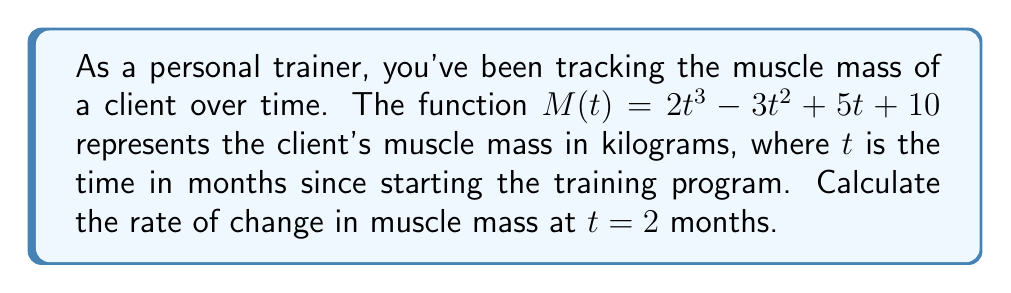Teach me how to tackle this problem. To find the rate of change in muscle mass at a specific point in time, we need to calculate the derivative of the given function and evaluate it at the specified time.

1. Given function: $M(t) = 2t^3 - 3t^2 + 5t + 10$

2. Calculate the derivative $M'(t)$ using the power rule and constant rule:
   $M'(t) = \frac{d}{dt}(2t^3 - 3t^2 + 5t + 10)$
   $M'(t) = 6t^2 - 6t + 5$

3. The derivative $M'(t)$ represents the instantaneous rate of change of muscle mass with respect to time.

4. To find the rate of change at $t = 2$ months, we evaluate $M'(2)$:
   $M'(2) = 6(2)^2 - 6(2) + 5$
   $M'(2) = 6(4) - 12 + 5$
   $M'(2) = 24 - 12 + 5$
   $M'(2) = 17$

Thus, the rate of change in muscle mass at $t = 2$ months is 17 kg/month.
Answer: $17$ kg/month 